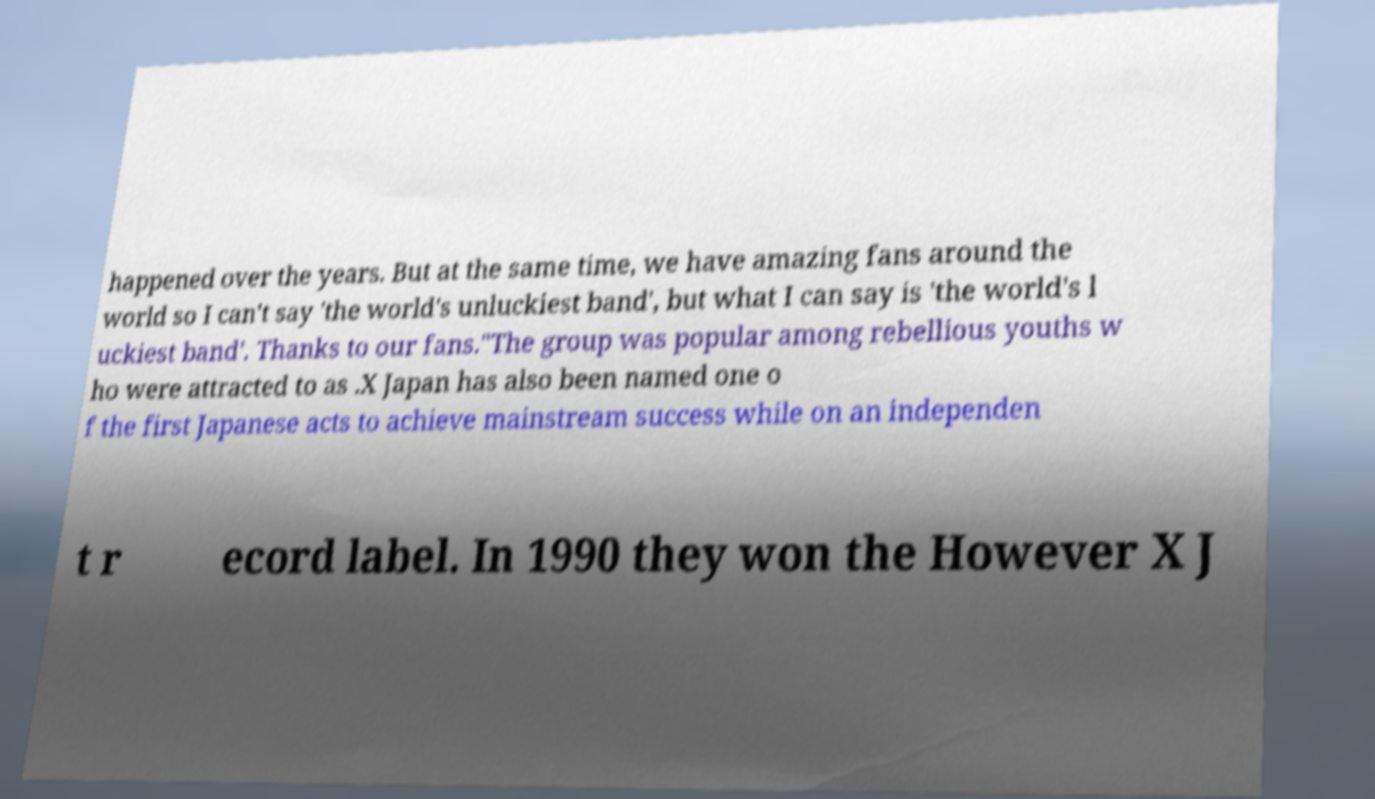For documentation purposes, I need the text within this image transcribed. Could you provide that? happened over the years. But at the same time, we have amazing fans around the world so I can't say 'the world's unluckiest band', but what I can say is 'the world's l uckiest band'. Thanks to our fans."The group was popular among rebellious youths w ho were attracted to as .X Japan has also been named one o f the first Japanese acts to achieve mainstream success while on an independen t r ecord label. In 1990 they won the However X J 